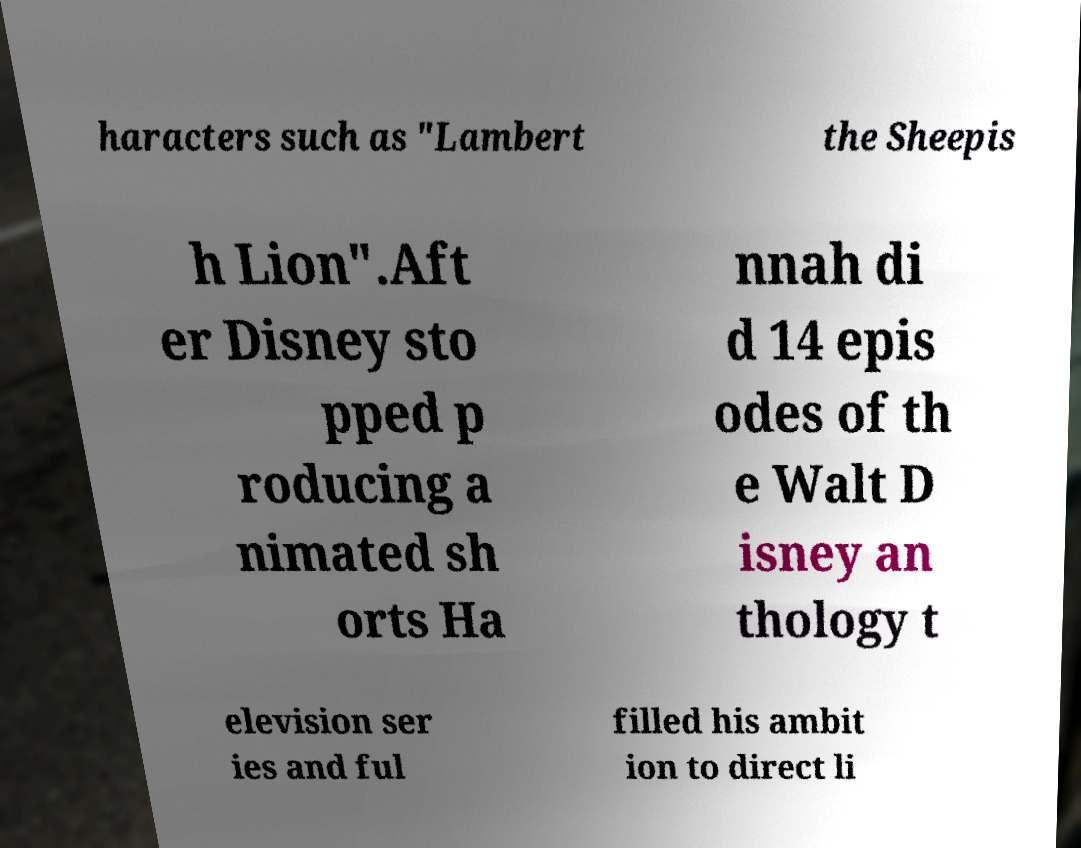What messages or text are displayed in this image? I need them in a readable, typed format. haracters such as "Lambert the Sheepis h Lion".Aft er Disney sto pped p roducing a nimated sh orts Ha nnah di d 14 epis odes of th e Walt D isney an thology t elevision ser ies and ful filled his ambit ion to direct li 